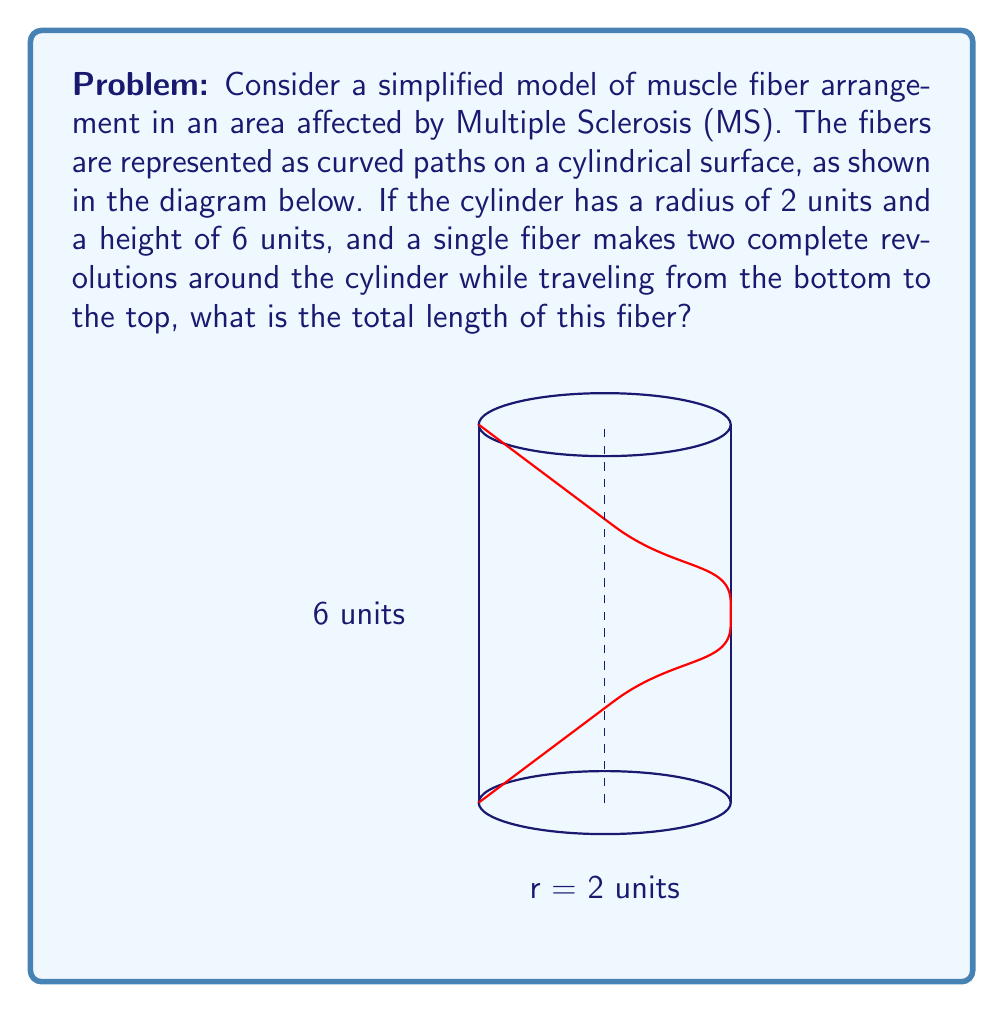Show me your answer to this math problem. To solve this problem, we'll follow these steps:

1) The path of the fiber forms a helix on the surface of the cylinder. We can parameterize this helix as:

   $$x(t) = r \cos(\frac{4\pi t}{h}), y(t) = r \sin(\frac{4\pi t}{h}), z(t) = t$$

   where $r = 2$ is the radius, $h = 6$ is the height, and $t$ goes from 0 to 6.

2) The length of a parametric curve is given by the integral:

   $$L = \int_0^h \sqrt{(\frac{dx}{dt})^2 + (\frac{dy}{dt})^2 + (\frac{dz}{dt})^2} dt$$

3) Let's calculate the derivatives:

   $$\frac{dx}{dt} = -\frac{4\pi r}{h} \sin(\frac{4\pi t}{h})$$
   $$\frac{dy}{dt} = \frac{4\pi r}{h} \cos(\frac{4\pi t}{h})$$
   $$\frac{dz}{dt} = 1$$

4) Substituting these into the integral:

   $$L = \int_0^6 \sqrt{(\frac{8\pi}{6})^2 (\sin^2(\frac{4\pi t}{6}) + \cos^2(\frac{4\pi t}{6})) + 1} dt$$

5) Simplify using $\sin^2 + \cos^2 = 1$:

   $$L = \int_0^6 \sqrt{(\frac{8\pi}{6})^2 + 1} dt$$

6) This simplifies to:

   $$L = 6 \sqrt{(\frac{8\pi}{6})^2 + 1} = 6 \sqrt{\frac{16\pi^2}{9} + 1}$$

7) Evaluating this expression:

   $$L = 6 \sqrt{\frac{16\pi^2 + 9}{9}} \approx 22.62 \text{ units}$$
Answer: $6 \sqrt{\frac{16\pi^2 + 9}{9}}$ units 